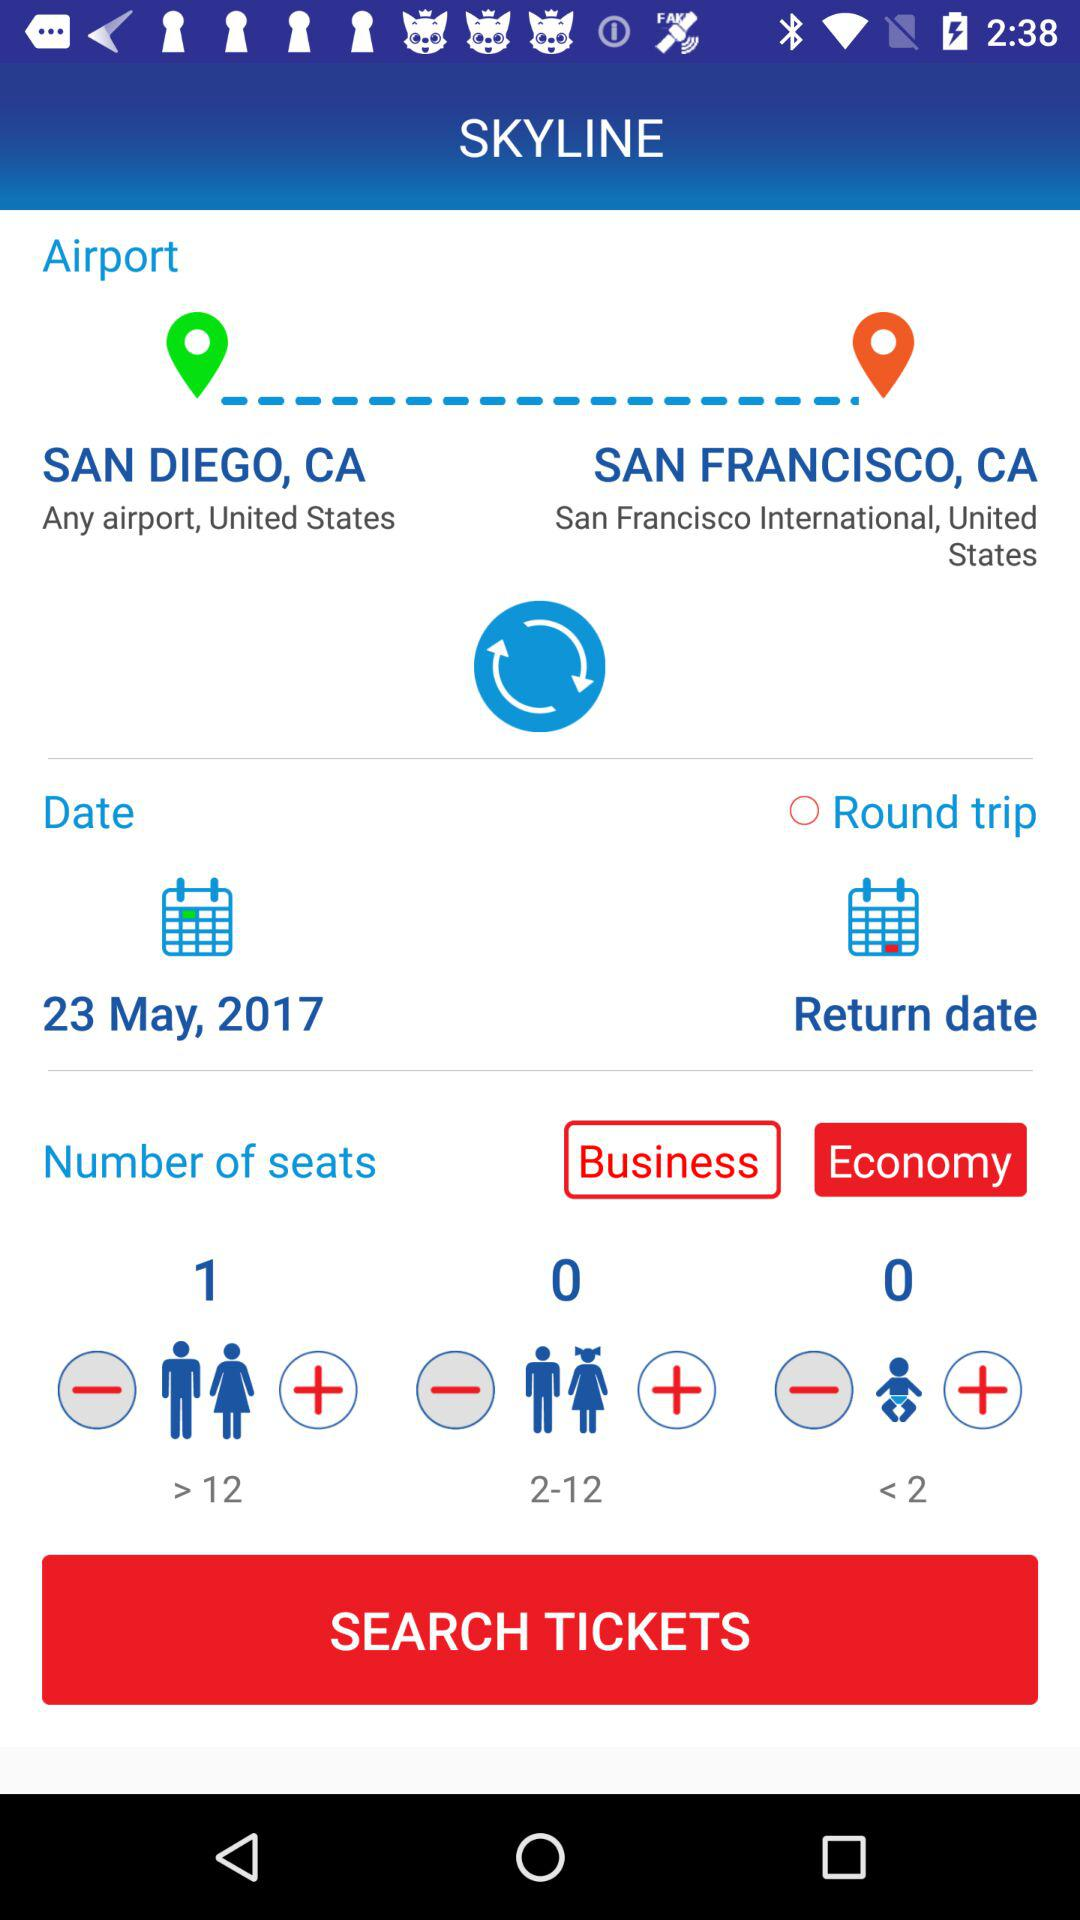Which day of the week does the flight depart?
When the provided information is insufficient, respond with <no answer>. <no answer> 